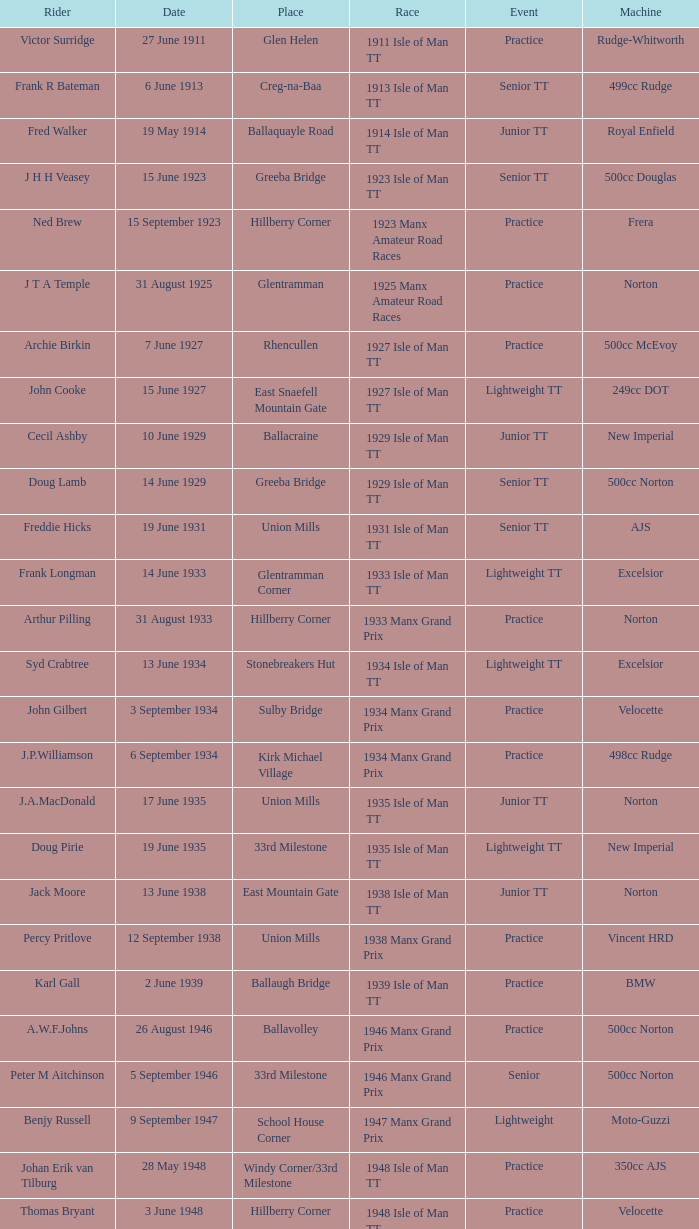When does harry l stephen ride a norton machine? 8 June 1953. 